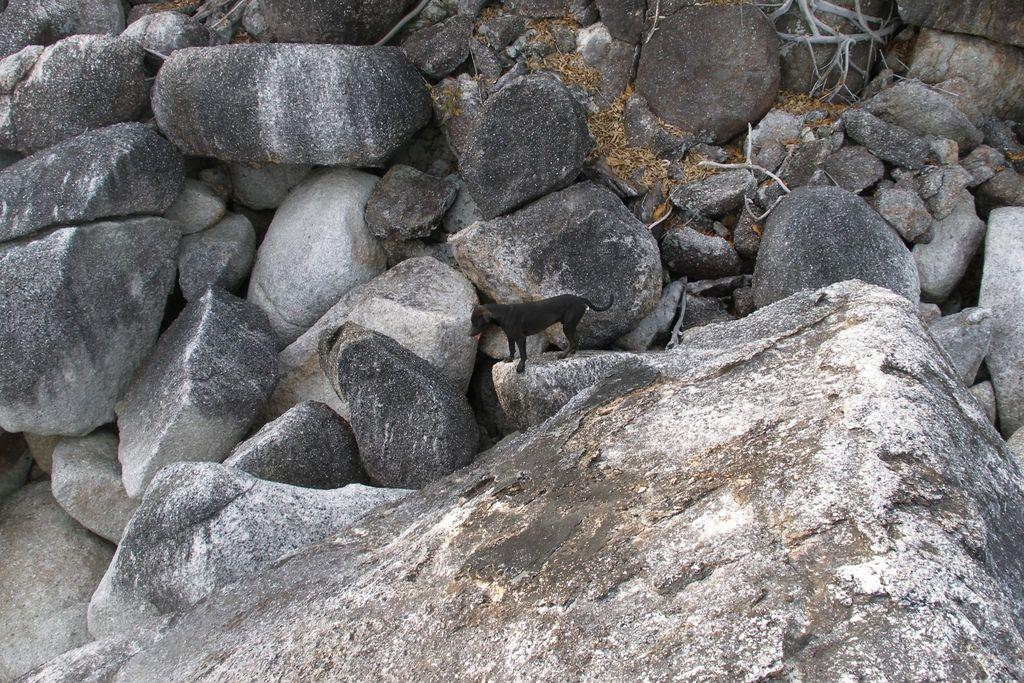What type of natural formation can be seen in the image? There are rocks in the image. Is there any living creature present on the rocks? Yes, there is a dog on one of the rocks. What type of apparel is the dog wearing in the image? There is no mention of the dog wearing any apparel in the image. 